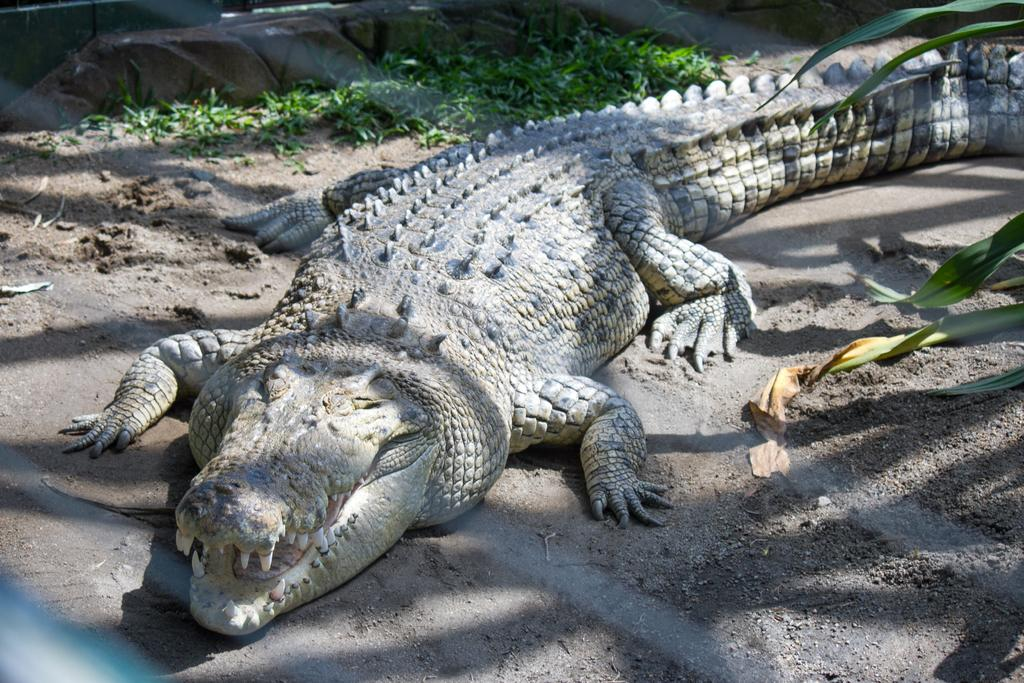What animal is the main subject of the picture? There is a crocodile in the picture. What type of environment is the crocodile in? There is grass beside the crocodile, suggesting a natural setting. What is located at the bottom of the picture? There is fencing at the bottom of the picture. What type of apparatus is being used by the crocodile in the picture? There is no apparatus present in the image; the crocodile is simply in its natural environment. How does the crocodile start its day in the picture? The image does not provide information about the crocodile's daily routine or activities. 